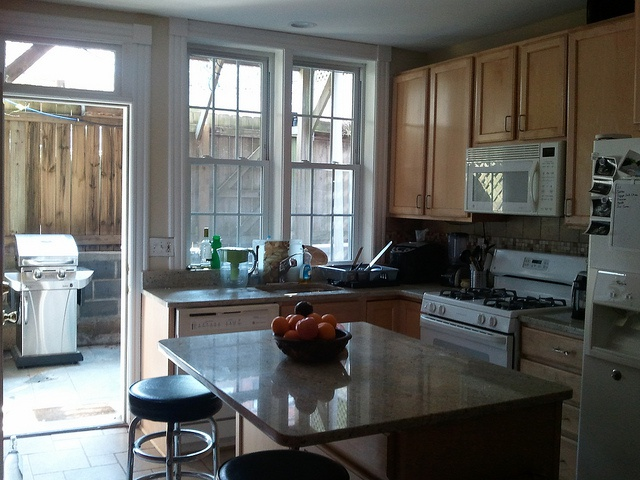Describe the objects in this image and their specific colors. I can see dining table in black and gray tones, refrigerator in black and gray tones, oven in black, gray, and purple tones, microwave in black, gray, darkgray, and beige tones, and chair in black and gray tones in this image. 